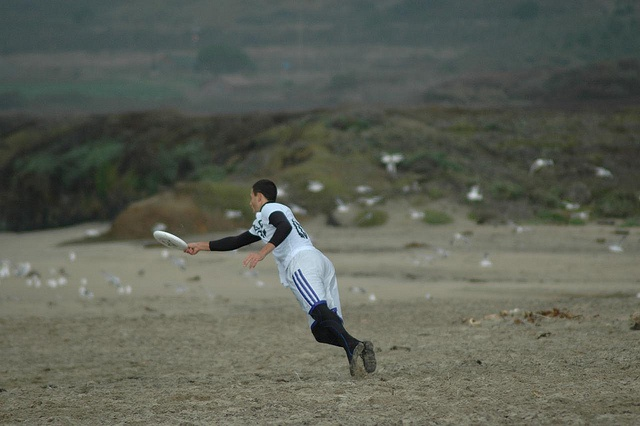Describe the objects in this image and their specific colors. I can see people in purple, black, darkgray, lightblue, and gray tones, frisbee in purple, gray, darkgray, and lightgray tones, bird in purple, gray, and darkgray tones, bird in purple, gray, darkgray, and darkgreen tones, and bird in purple, gray, darkgray, and darkgreen tones in this image. 